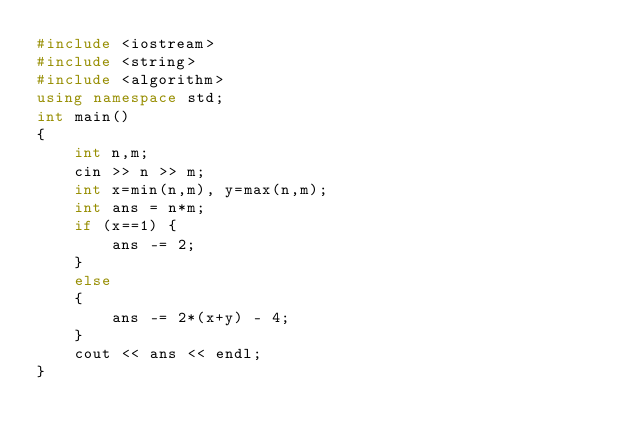Convert code to text. <code><loc_0><loc_0><loc_500><loc_500><_C++_>#include <iostream>
#include <string>
#include <algorithm>
using namespace std;
int main()
{
    int n,m;
    cin >> n >> m;
    int x=min(n,m), y=max(n,m);
    int ans = n*m;
    if (x==1) {
        ans -= 2;
    }
    else
    {
        ans -= 2*(x+y) - 4;
    }
    cout << ans << endl;
}</code> 